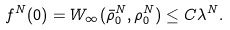<formula> <loc_0><loc_0><loc_500><loc_500>f ^ { N } ( 0 ) = W _ { \infty } ( \bar { \rho } ^ { N } _ { 0 } , \rho ^ { N } _ { 0 } ) \leq C \lambda ^ { N } .</formula> 